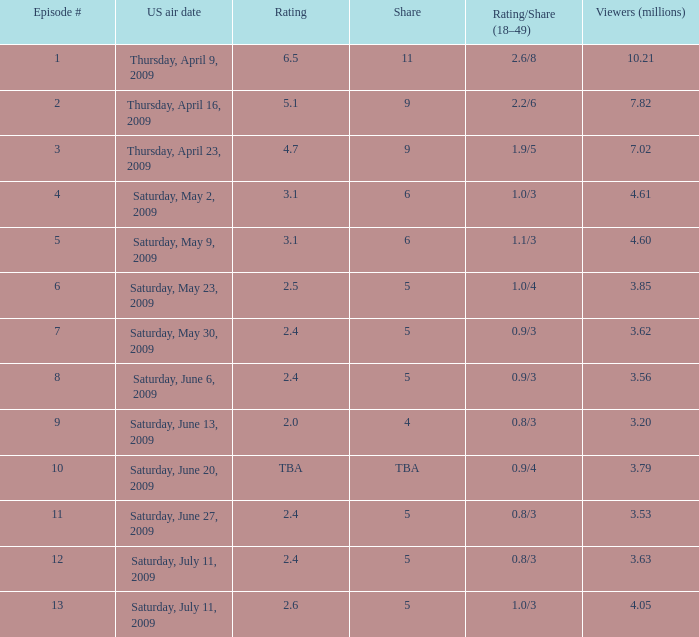What is the typical amount of million viewers who watched an episode preceding episode 11 with a 4 share? 3.2. 